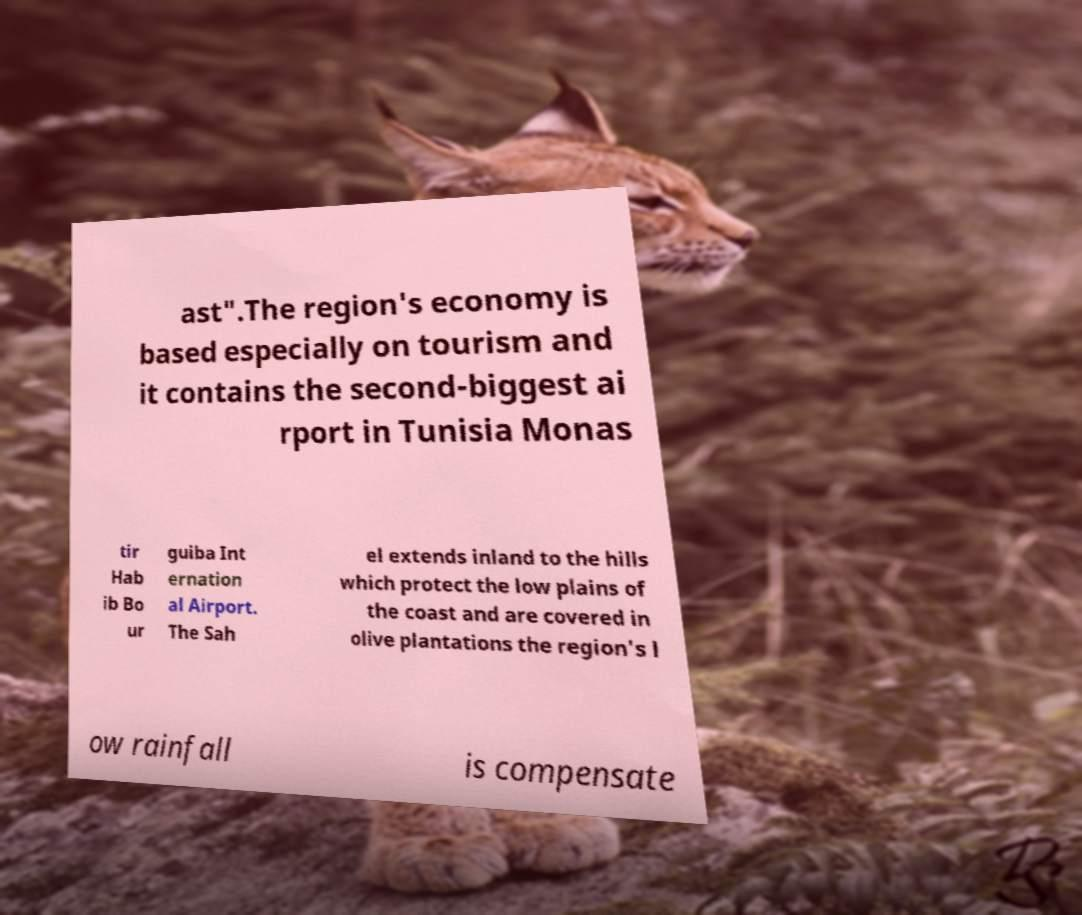Could you assist in decoding the text presented in this image and type it out clearly? ast".The region's economy is based especially on tourism and it contains the second-biggest ai rport in Tunisia Monas tir Hab ib Bo ur guiba Int ernation al Airport. The Sah el extends inland to the hills which protect the low plains of the coast and are covered in olive plantations the region's l ow rainfall is compensate 